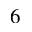<formula> <loc_0><loc_0><loc_500><loc_500>_ { 6 }</formula> 